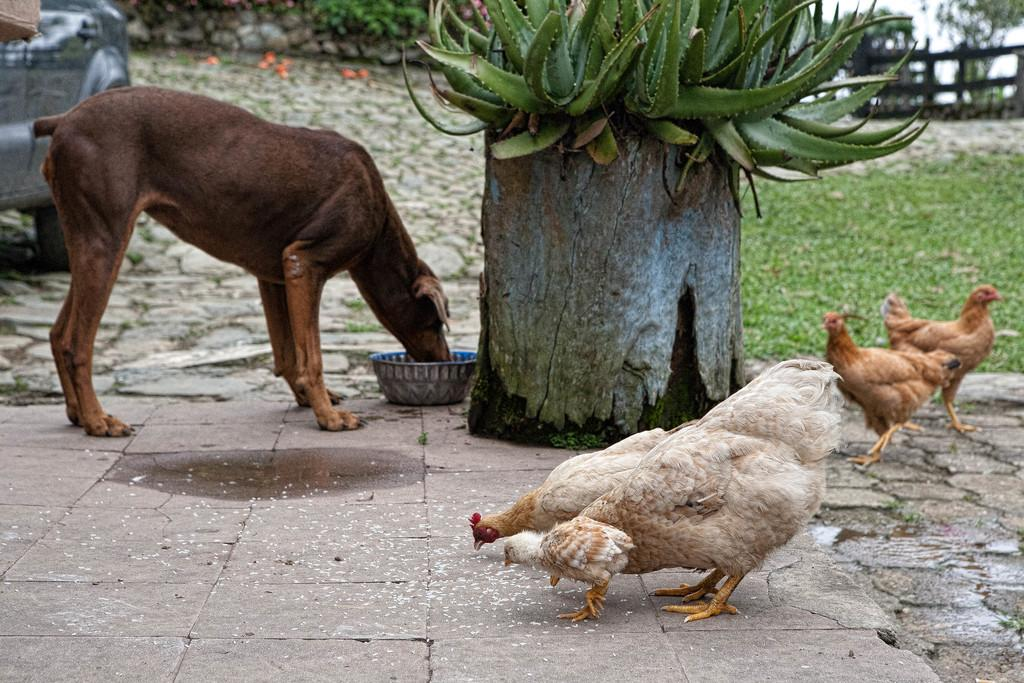What type of animal can be seen in the image? There is a dog in the image. What other animals are present in the image? There are hens in the image. What object can be seen in the image that might be used for holding food or water? There is a bowl in the image. What type of vegetation is visible in the image? There are plants and grass in the image. What type of barrier is present in the image? There is a fence in the image. What can be seen in the background of the image? There are trees in the background of the image. How much credit does the dog have in the image? There is no mention of credit in the image, as it is a photograph and not a financial transaction. 